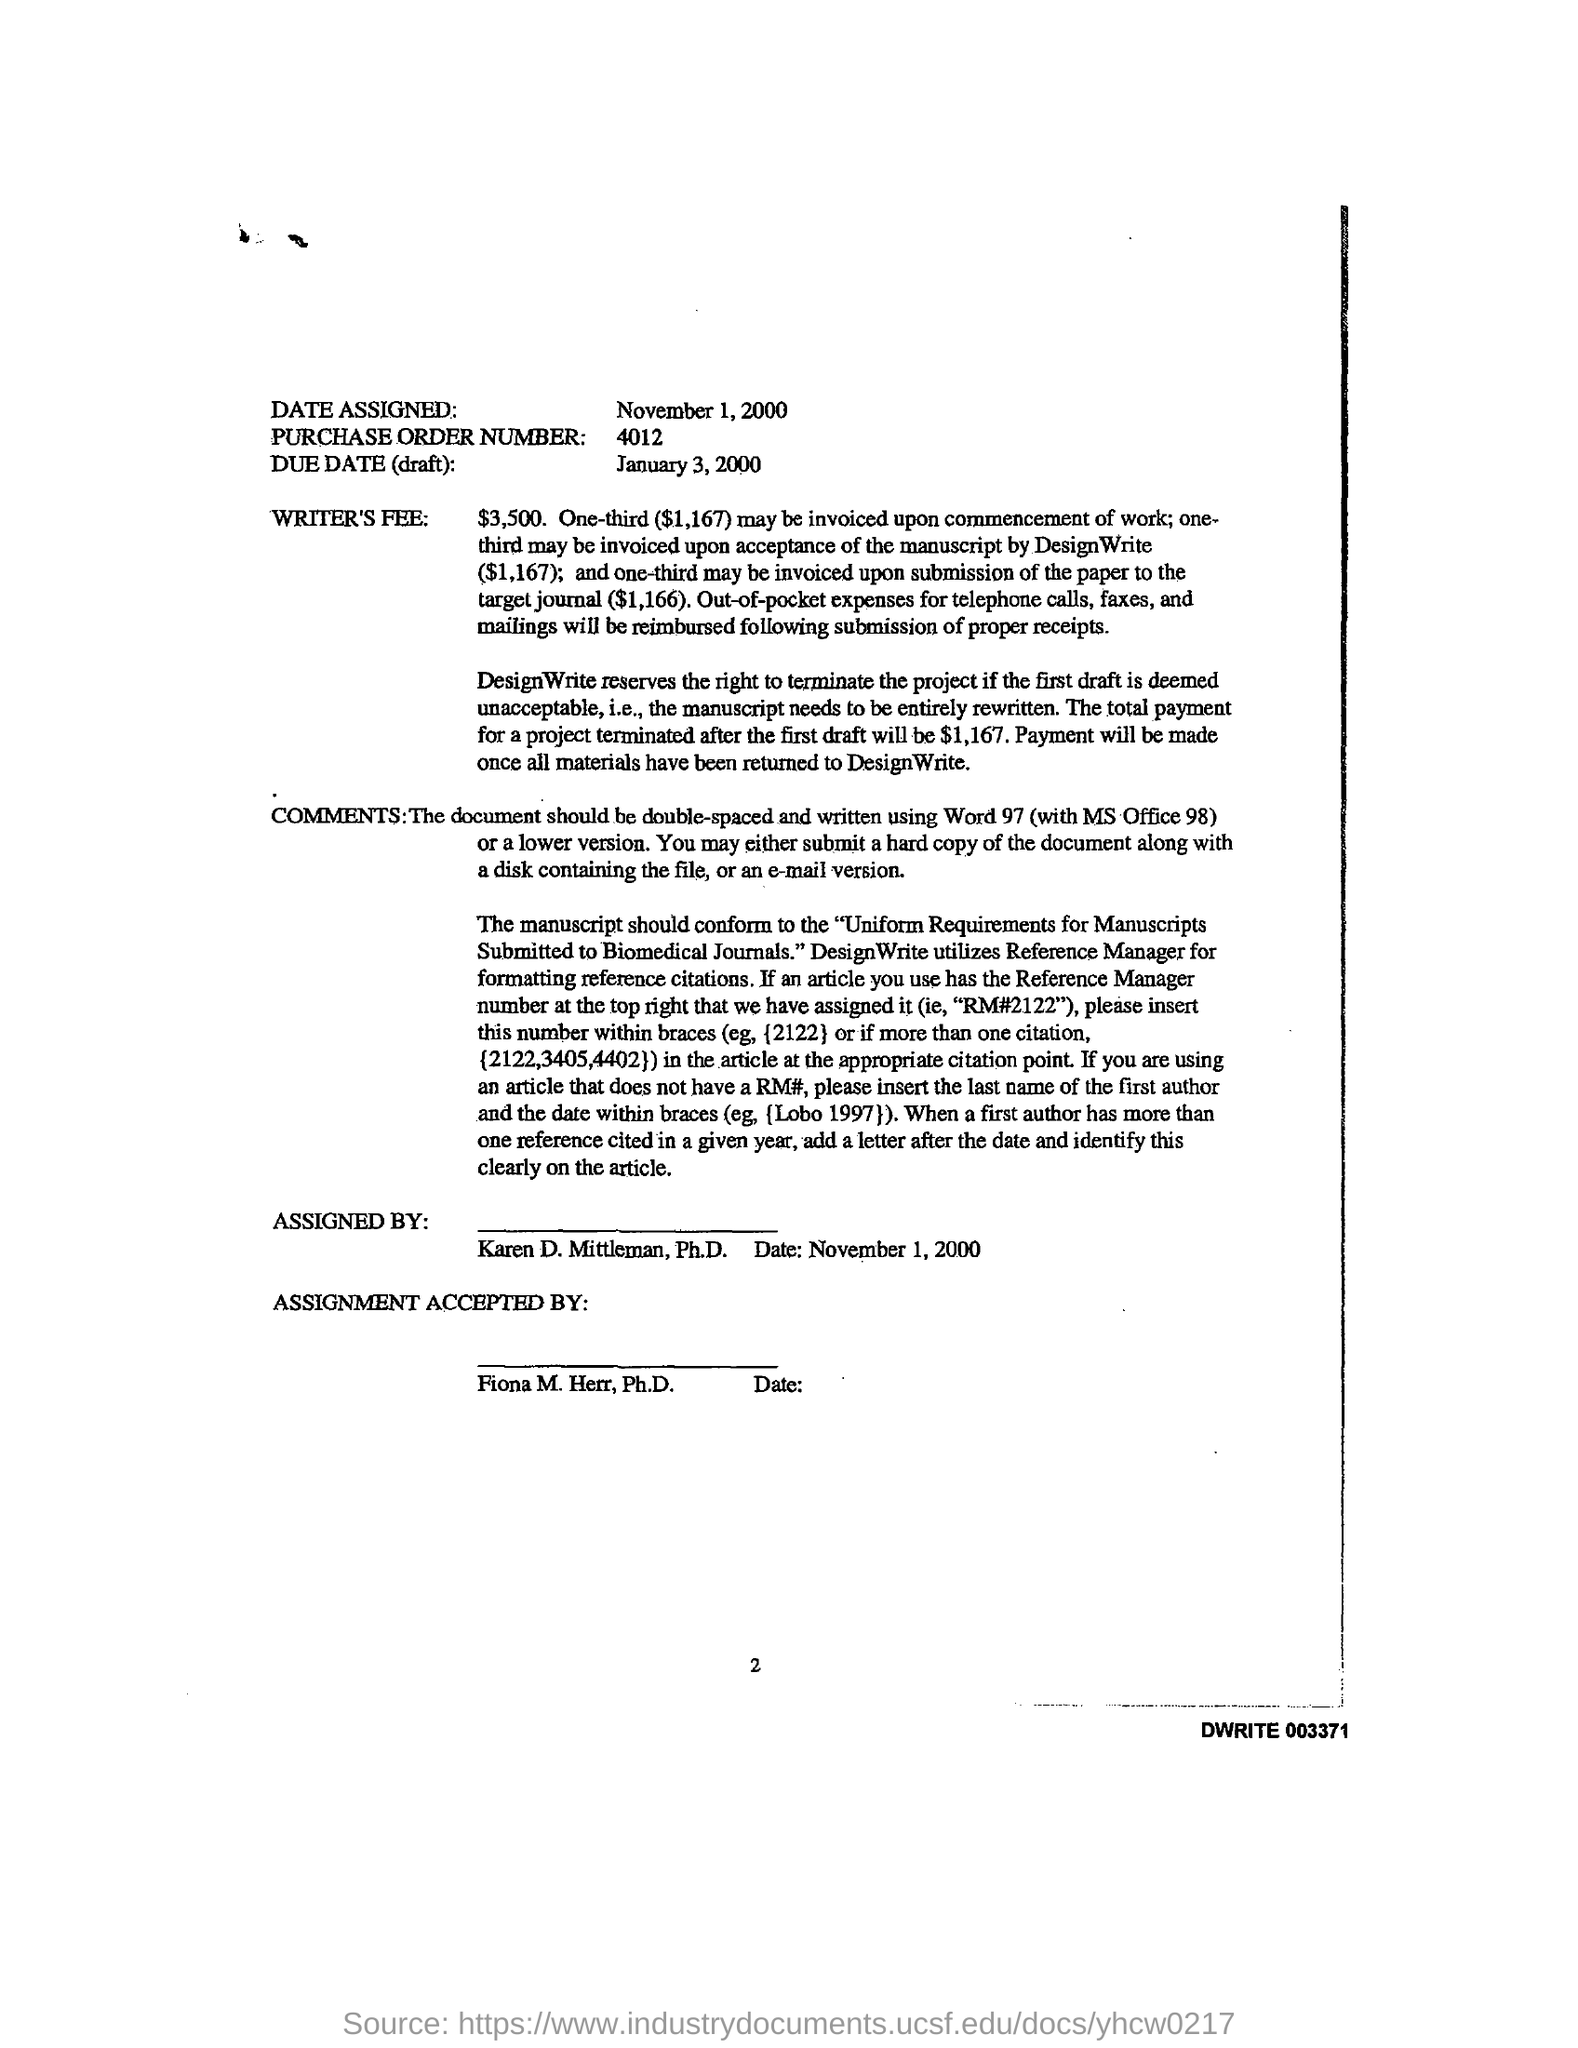What is assigned date?
Offer a terse response. November 1, 2000. Who reserve rights to terminate project?
Keep it short and to the point. DesignWrite. What is purchase order number?
Ensure brevity in your answer.  4012. 